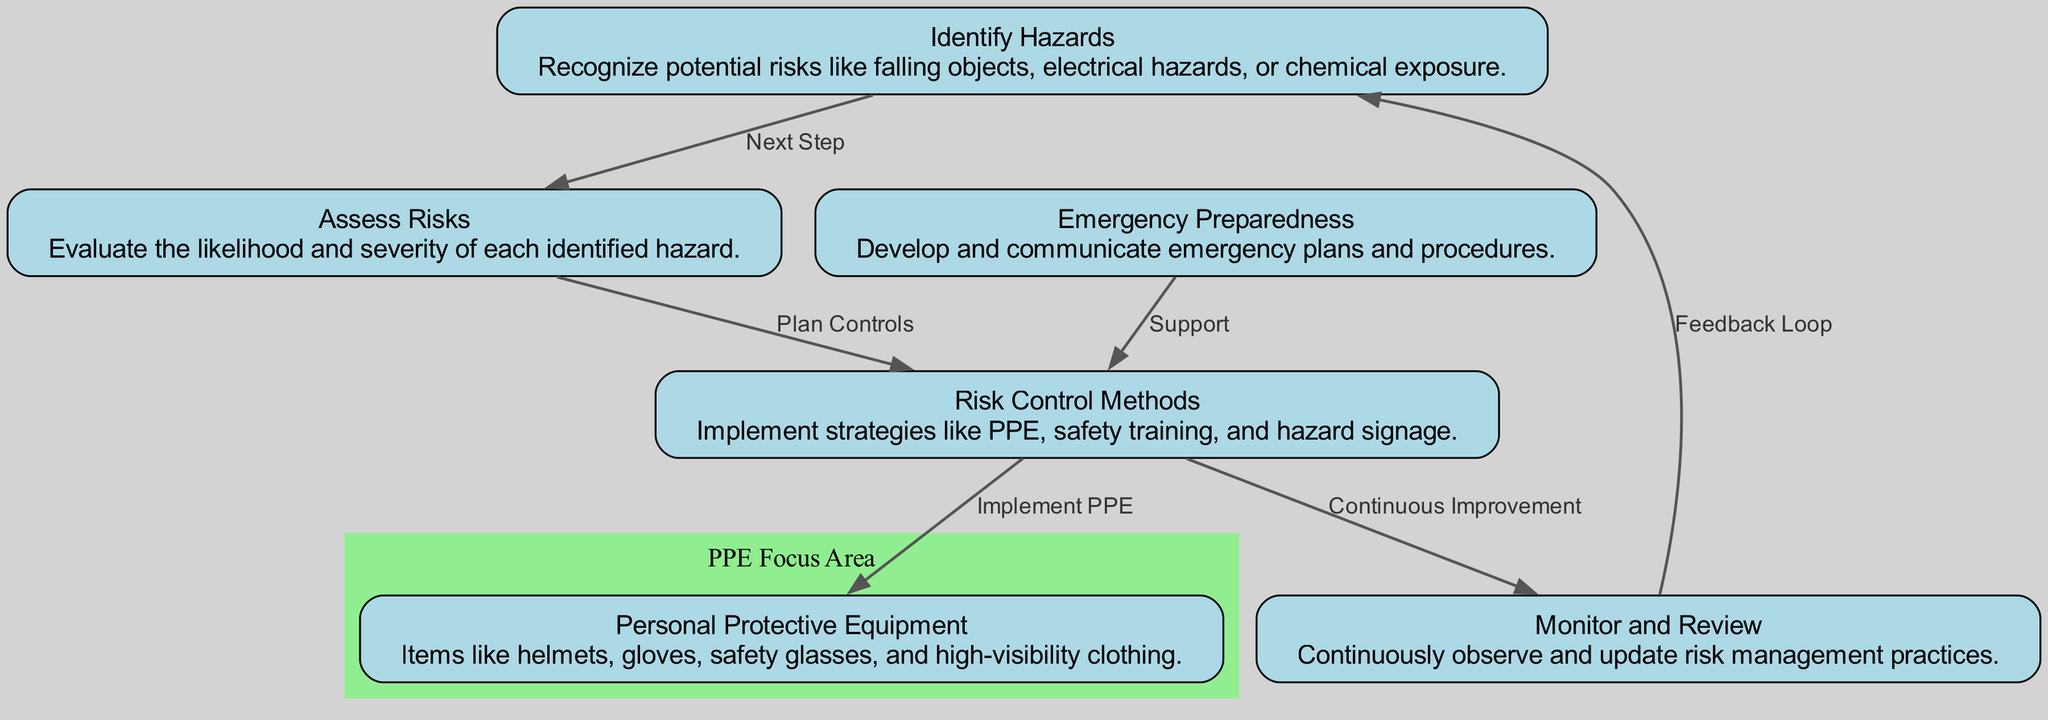What is the first step in risk management? The diagram shows that the first step is "Identify Hazards," indicating it as the initial action in the risk management process.
Answer: Identify Hazards How many nodes are there in the diagram? By counting all the unique nodes listed, we see that there are six nodes present in the diagram.
Answer: 6 What relationship exists between "Assess Risks" and "Risk Control Methods"? The diagram indicates that "Assess Risks" leads to "Risk Control Methods," labeled as "Plan Controls," showing a direct relationship between these two processes.
Answer: Plan Controls Which node provides emergency support? The node titled "Emergency Preparedness" provides support to "Risk Control Methods," as indicated by the edge connecting these two nodes labeled "Support."
Answer: Emergency Preparedness What type of equipment is detailed under Personal Protective Equipment? The description under "Personal Protective Equipment" lists items like helmets, gloves, safety glasses, and high-visibility clothing, indicating what specific types of gear are included.
Answer: Helmets, gloves, safety glasses, high-visibility clothing What is the final step that connects back to "Identify Hazards"? The "Monitor and Review" node connects back to "Identify Hazards" through a feedback loop, which is indicated in the diagram as part of the continuous improvement process.
Answer: Feedback Loop How does "Emergency Preparedness" relate to the risk control methods? "Emergency Preparedness" directly connects to "Risk Control Methods" in the diagram, annotated with the directional label "Support," showing its importance in risk control.
Answer: Support What is the purpose of monitoring and reviewing in risk management? The function of "Monitor and Review" is to continuously observe and update risk management practices, as detailed in the description of this node in the diagram.
Answer: Continuously observe and update What does the feedback loop indicate in this risk management process? The feedback loop indicates that after monitoring and reviewing, there is an assessment of hazards again, maintaining a cycle of improvement and awareness of potential risks.
Answer: Continuous improvement cycle 